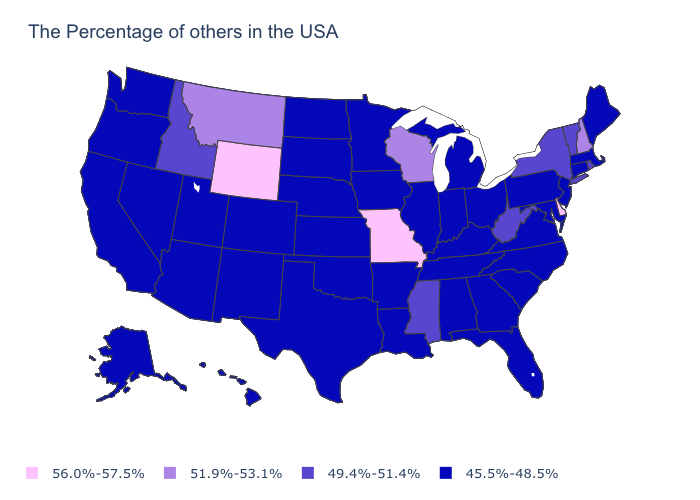What is the value of Arkansas?
Keep it brief. 45.5%-48.5%. Which states hav the highest value in the West?
Concise answer only. Wyoming. Does Pennsylvania have a higher value than New Mexico?
Keep it brief. No. What is the value of Rhode Island?
Be succinct. 49.4%-51.4%. What is the value of Massachusetts?
Short answer required. 45.5%-48.5%. Does Connecticut have the same value as Montana?
Short answer required. No. Does West Virginia have the lowest value in the USA?
Answer briefly. No. Name the states that have a value in the range 49.4%-51.4%?
Answer briefly. Rhode Island, Vermont, New York, West Virginia, Mississippi, Idaho. Name the states that have a value in the range 56.0%-57.5%?
Keep it brief. Delaware, Missouri, Wyoming. Is the legend a continuous bar?
Short answer required. No. What is the value of Nebraska?
Short answer required. 45.5%-48.5%. Does North Carolina have the lowest value in the USA?
Concise answer only. Yes. What is the value of North Carolina?
Concise answer only. 45.5%-48.5%. Among the states that border Kansas , does Oklahoma have the lowest value?
Give a very brief answer. Yes. Among the states that border Colorado , which have the highest value?
Give a very brief answer. Wyoming. 